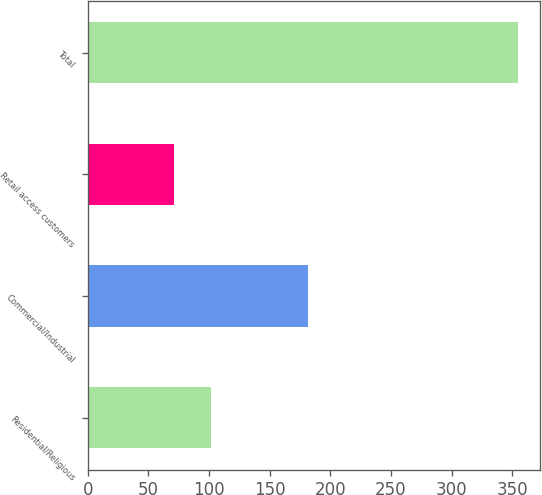<chart> <loc_0><loc_0><loc_500><loc_500><bar_chart><fcel>Residential/Religious<fcel>Commercial/Industrial<fcel>Retail access customers<fcel>Total<nl><fcel>102<fcel>182<fcel>71<fcel>355<nl></chart> 